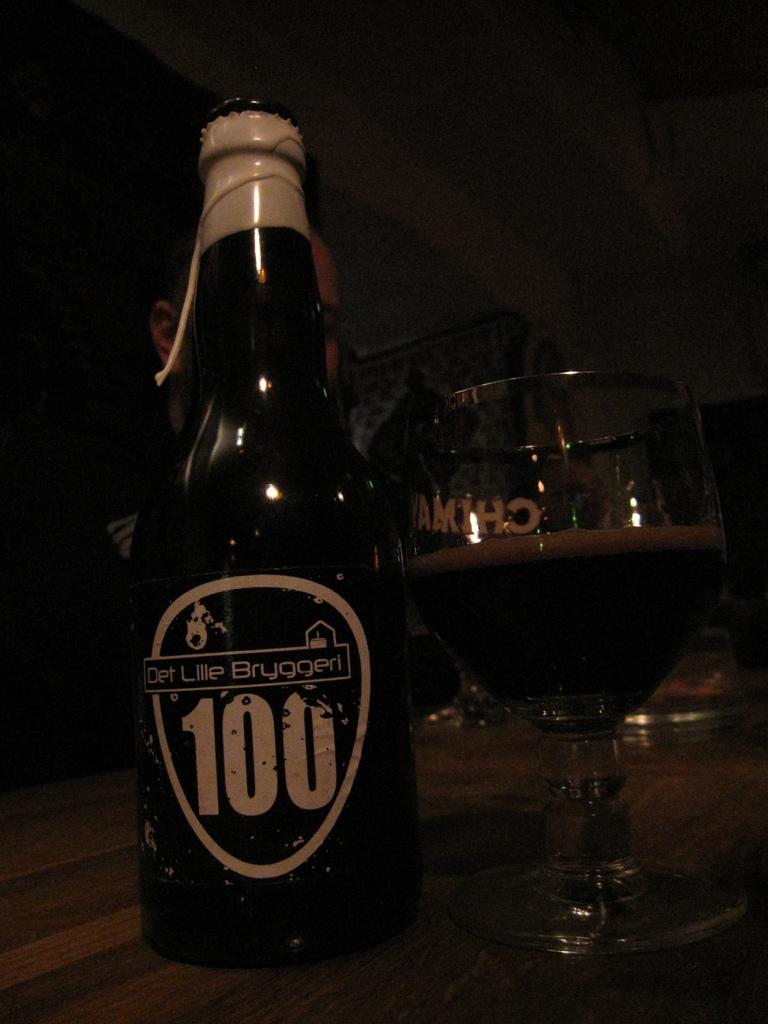<image>
Create a compact narrative representing the image presented. A bottle with the number 100 includes on the label sits by a half full glass. 